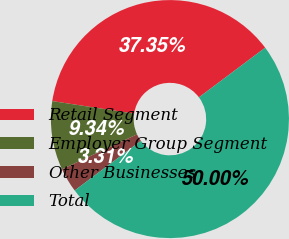Convert chart to OTSL. <chart><loc_0><loc_0><loc_500><loc_500><pie_chart><fcel>Retail Segment<fcel>Employer Group Segment<fcel>Other Businesses<fcel>Total<nl><fcel>37.35%<fcel>9.34%<fcel>3.31%<fcel>50.0%<nl></chart> 